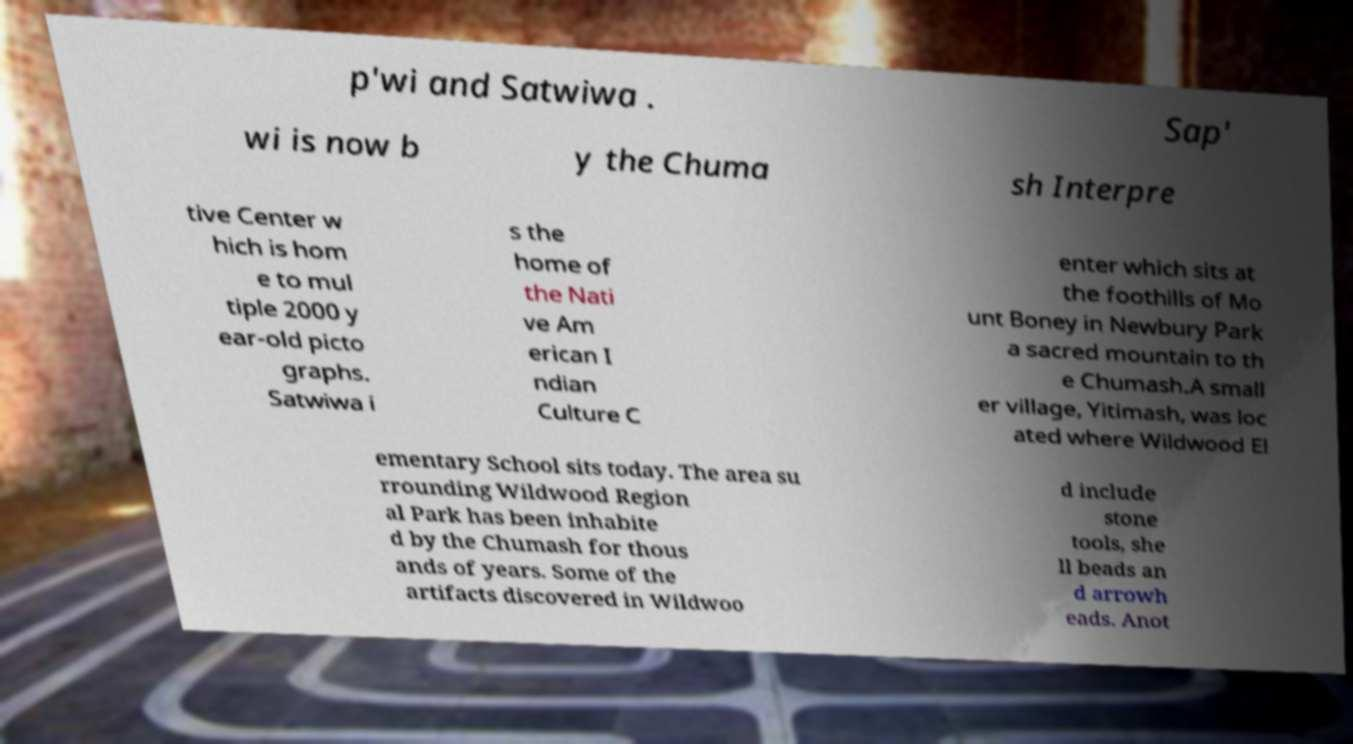What messages or text are displayed in this image? I need them in a readable, typed format. p'wi and Satwiwa . Sap' wi is now b y the Chuma sh Interpre tive Center w hich is hom e to mul tiple 2000 y ear-old picto graphs. Satwiwa i s the home of the Nati ve Am erican I ndian Culture C enter which sits at the foothills of Mo unt Boney in Newbury Park a sacred mountain to th e Chumash.A small er village, Yitimash, was loc ated where Wildwood El ementary School sits today. The area su rrounding Wildwood Region al Park has been inhabite d by the Chumash for thous ands of years. Some of the artifacts discovered in Wildwoo d include stone tools, she ll beads an d arrowh eads. Anot 